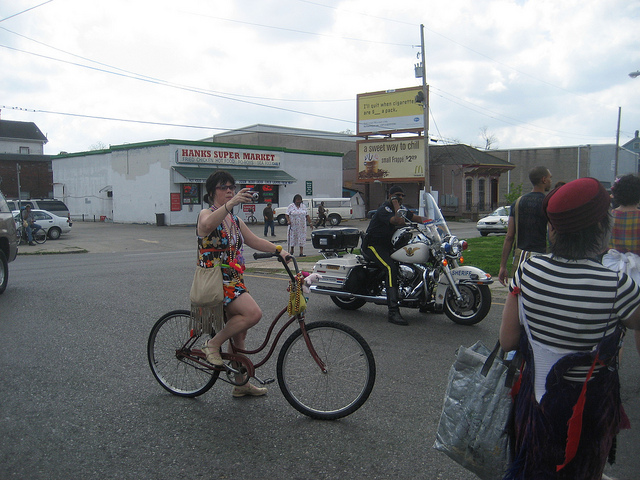<image>Which man has a red hat? I don't know which man has a red hat. It seems there is no man with a red hat in the image. Which man has a red hat? I am not sure which man has a red hat. It is ambiguous. 